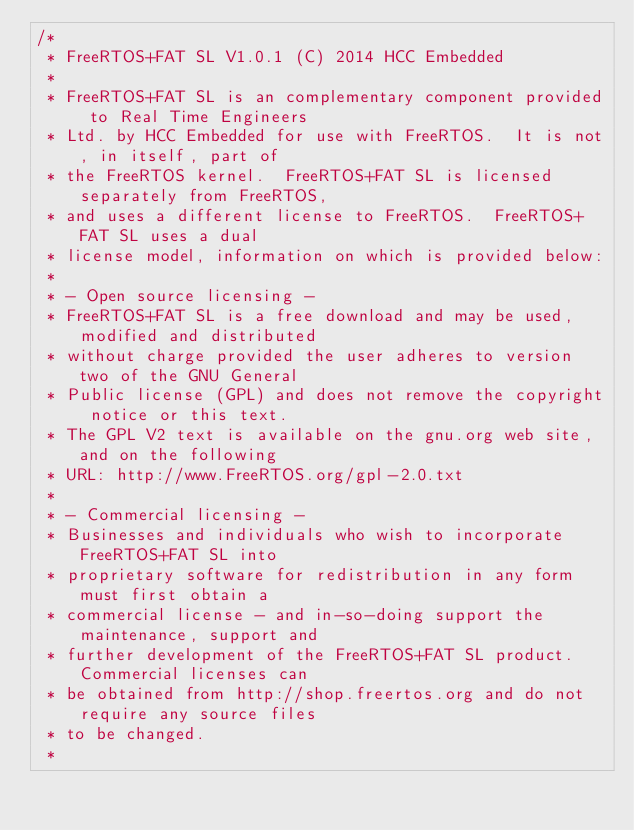Convert code to text. <code><loc_0><loc_0><loc_500><loc_500><_C_>/*
 * FreeRTOS+FAT SL V1.0.1 (C) 2014 HCC Embedded
 *
 * FreeRTOS+FAT SL is an complementary component provided to Real Time Engineers
 * Ltd. by HCC Embedded for use with FreeRTOS.  It is not, in itself, part of
 * the FreeRTOS kernel.  FreeRTOS+FAT SL is licensed separately from FreeRTOS,
 * and uses a different license to FreeRTOS.  FreeRTOS+FAT SL uses a dual
 * license model, information on which is provided below:
 *
 * - Open source licensing -
 * FreeRTOS+FAT SL is a free download and may be used, modified and distributed
 * without charge provided the user adheres to version two of the GNU General
 * Public license (GPL) and does not remove the copyright notice or this text.
 * The GPL V2 text is available on the gnu.org web site, and on the following
 * URL: http://www.FreeRTOS.org/gpl-2.0.txt
 *
 * - Commercial licensing -
 * Businesses and individuals who wish to incorporate FreeRTOS+FAT SL into
 * proprietary software for redistribution in any form must first obtain a
 * commercial license - and in-so-doing support the maintenance, support and
 * further development of the FreeRTOS+FAT SL product.  Commercial licenses can
 * be obtained from http://shop.freertos.org and do not require any source files
 * to be changed.
 *</code> 